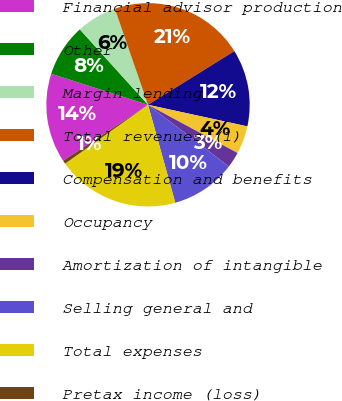Convert chart. <chart><loc_0><loc_0><loc_500><loc_500><pie_chart><fcel>Financial advisor production<fcel>Other<fcel>Margin lending<fcel>Total revenues (1)<fcel>Compensation and benefits<fcel>Occupancy<fcel>Amortization of intangible<fcel>Selling general and<fcel>Total expenses<fcel>Pretax income (loss)<nl><fcel>14.21%<fcel>8.36%<fcel>6.41%<fcel>21.45%<fcel>12.26%<fcel>4.46%<fcel>2.51%<fcel>10.31%<fcel>19.5%<fcel>0.56%<nl></chart> 